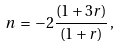<formula> <loc_0><loc_0><loc_500><loc_500>n \, = \, - 2 \frac { ( 1 + 3 r ) } { ( 1 + r ) } \, ,</formula> 